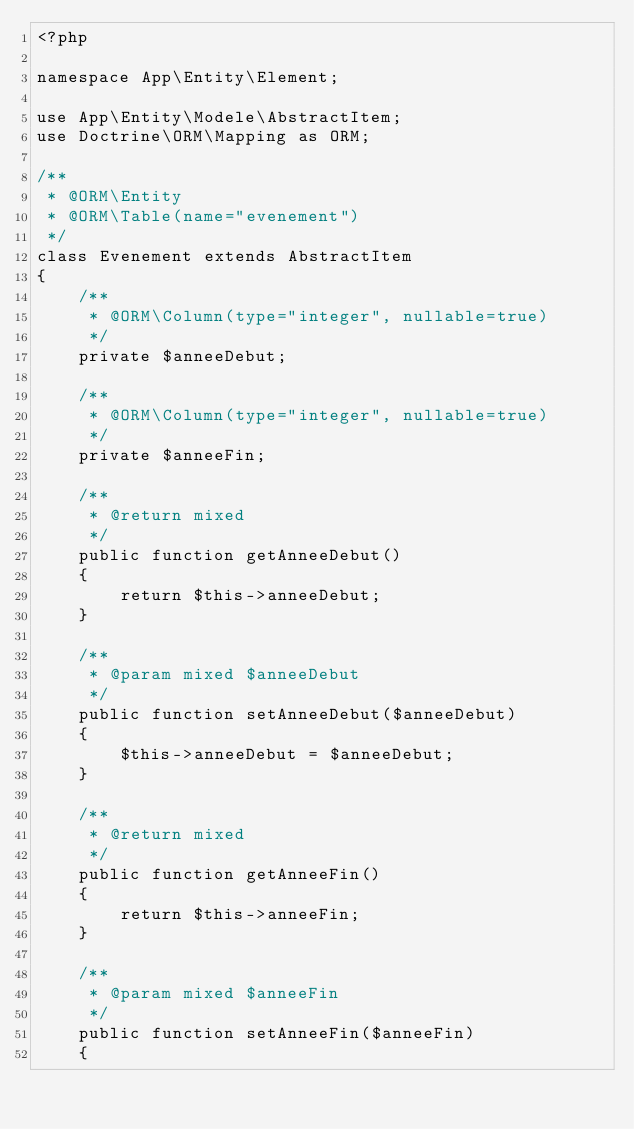Convert code to text. <code><loc_0><loc_0><loc_500><loc_500><_PHP_><?php

namespace App\Entity\Element;

use App\Entity\Modele\AbstractItem;
use Doctrine\ORM\Mapping as ORM;

/**
 * @ORM\Entity
 * @ORM\Table(name="evenement")
 */
class Evenement extends AbstractItem
{
    /**
     * @ORM\Column(type="integer", nullable=true)
     */
    private $anneeDebut;

    /**
     * @ORM\Column(type="integer", nullable=true)
     */
    private $anneeFin;

    /**
     * @return mixed
     */
    public function getAnneeDebut()
    {
        return $this->anneeDebut;
    }

    /**
     * @param mixed $anneeDebut
     */
    public function setAnneeDebut($anneeDebut)
    {
        $this->anneeDebut = $anneeDebut;
    }

    /**
     * @return mixed
     */
    public function getAnneeFin()
    {
        return $this->anneeFin;
    }

    /**
     * @param mixed $anneeFin
     */
    public function setAnneeFin($anneeFin)
    {</code> 